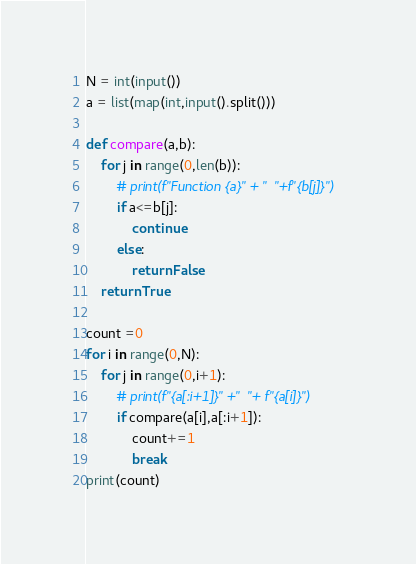Convert code to text. <code><loc_0><loc_0><loc_500><loc_500><_Python_>N = int(input())
a = list(map(int,input().split()))

def compare(a,b):
    for j in range(0,len(b)):
        # print(f"Function {a}" + "  "+f"{b[j]}")
        if a<=b[j]:
            continue
        else:
            return False
    return True

count =0
for i in range(0,N):
    for j in range(0,i+1):
        # print(f"{a[:i+1]}" +"  "+ f"{a[i]}")
        if compare(a[i],a[:i+1]):
            count+=1
            break
print(count)

</code> 